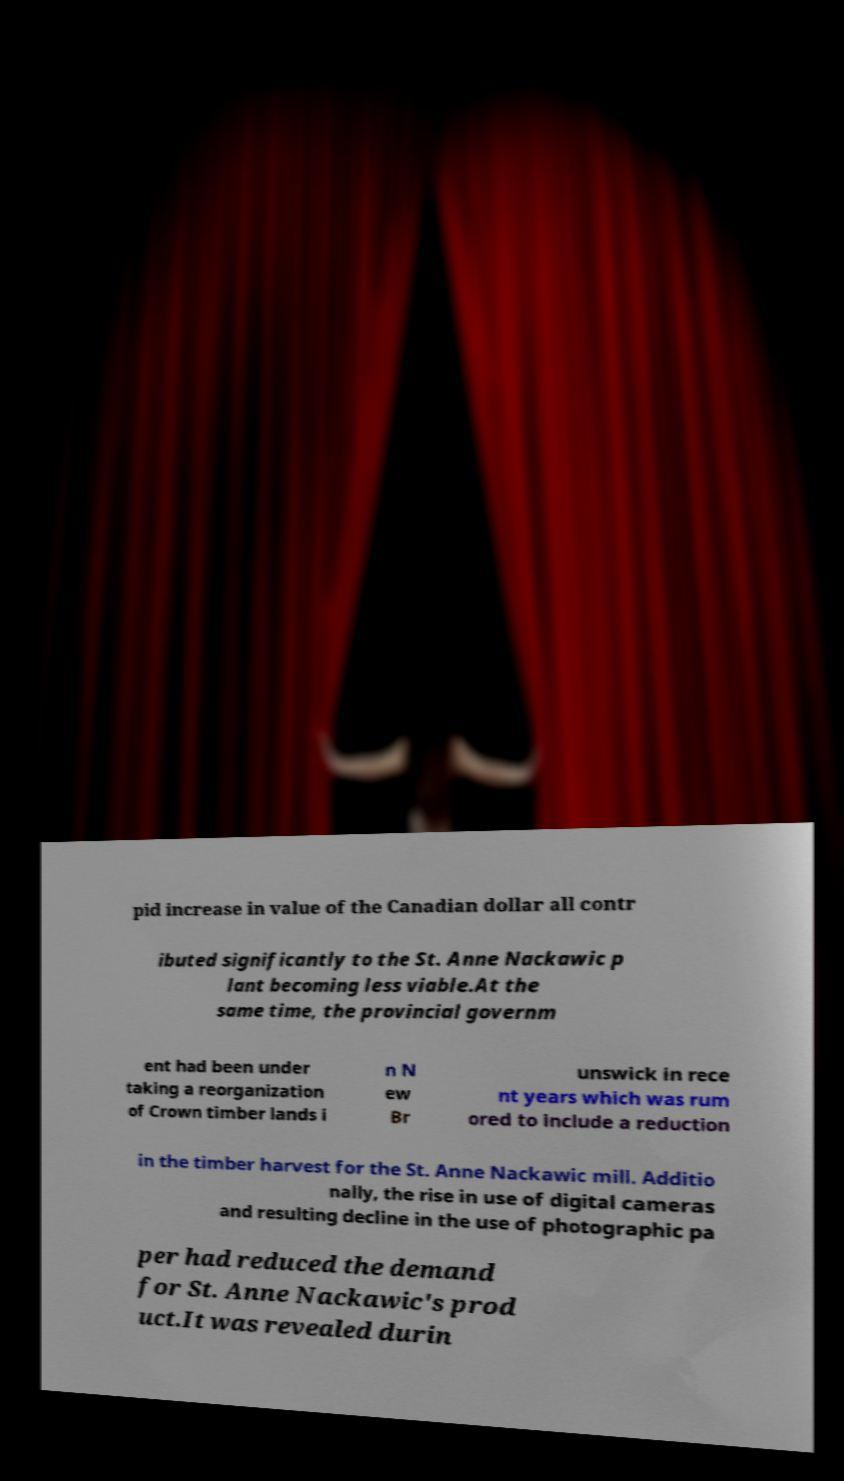Please identify and transcribe the text found in this image. pid increase in value of the Canadian dollar all contr ibuted significantly to the St. Anne Nackawic p lant becoming less viable.At the same time, the provincial governm ent had been under taking a reorganization of Crown timber lands i n N ew Br unswick in rece nt years which was rum ored to include a reduction in the timber harvest for the St. Anne Nackawic mill. Additio nally, the rise in use of digital cameras and resulting decline in the use of photographic pa per had reduced the demand for St. Anne Nackawic's prod uct.It was revealed durin 